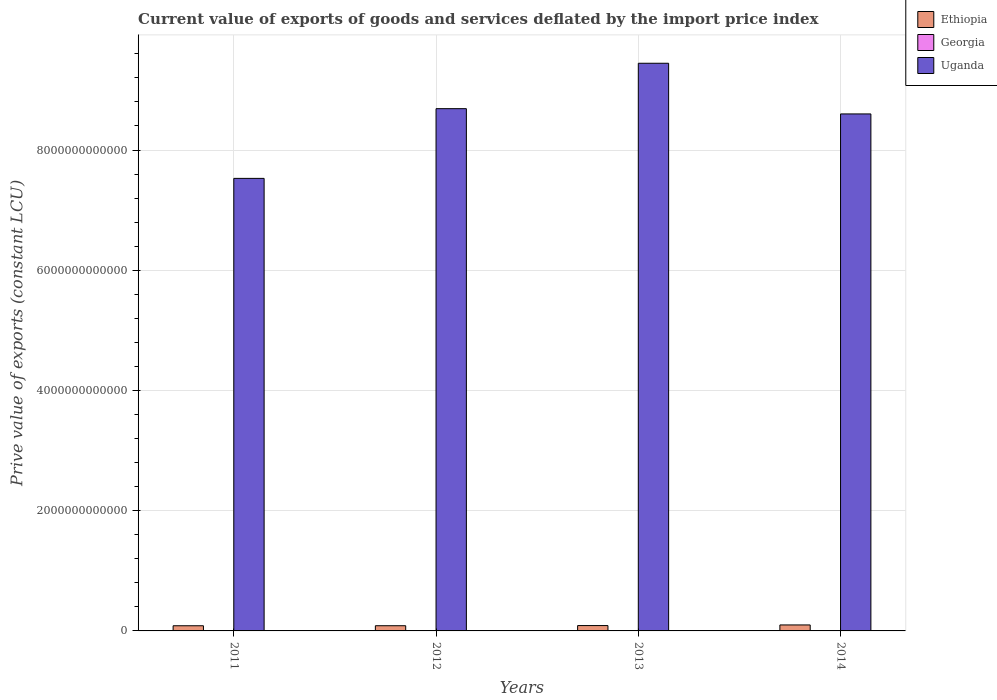How many different coloured bars are there?
Your response must be concise. 3. How many groups of bars are there?
Make the answer very short. 4. Are the number of bars on each tick of the X-axis equal?
Ensure brevity in your answer.  Yes. How many bars are there on the 3rd tick from the left?
Keep it short and to the point. 3. What is the prive value of exports in Ethiopia in 2013?
Your answer should be very brief. 8.91e+1. Across all years, what is the maximum prive value of exports in Georgia?
Keep it short and to the point. 4.46e+09. Across all years, what is the minimum prive value of exports in Uganda?
Offer a terse response. 7.53e+12. What is the total prive value of exports in Georgia in the graph?
Make the answer very short. 1.59e+1. What is the difference between the prive value of exports in Georgia in 2012 and that in 2014?
Keep it short and to the point. -7.93e+08. What is the difference between the prive value of exports in Uganda in 2012 and the prive value of exports in Georgia in 2013?
Make the answer very short. 8.68e+12. What is the average prive value of exports in Ethiopia per year?
Give a very brief answer. 9.02e+1. In the year 2011, what is the difference between the prive value of exports in Uganda and prive value of exports in Georgia?
Make the answer very short. 7.52e+12. What is the ratio of the prive value of exports in Georgia in 2012 to that in 2014?
Your answer should be compact. 0.82. Is the prive value of exports in Georgia in 2011 less than that in 2014?
Ensure brevity in your answer.  Yes. What is the difference between the highest and the second highest prive value of exports in Georgia?
Offer a terse response. 2.30e+07. What is the difference between the highest and the lowest prive value of exports in Georgia?
Your answer should be very brief. 1.18e+09. Is the sum of the prive value of exports in Uganda in 2013 and 2014 greater than the maximum prive value of exports in Georgia across all years?
Make the answer very short. Yes. What does the 3rd bar from the left in 2014 represents?
Give a very brief answer. Uganda. What does the 3rd bar from the right in 2013 represents?
Your answer should be very brief. Ethiopia. Are all the bars in the graph horizontal?
Ensure brevity in your answer.  No. How many years are there in the graph?
Your response must be concise. 4. What is the difference between two consecutive major ticks on the Y-axis?
Ensure brevity in your answer.  2.00e+12. Are the values on the major ticks of Y-axis written in scientific E-notation?
Keep it short and to the point. No. Does the graph contain grids?
Ensure brevity in your answer.  Yes. Where does the legend appear in the graph?
Your answer should be compact. Top right. What is the title of the graph?
Ensure brevity in your answer.  Current value of exports of goods and services deflated by the import price index. Does "Djibouti" appear as one of the legend labels in the graph?
Provide a succinct answer. No. What is the label or title of the Y-axis?
Ensure brevity in your answer.  Prive value of exports (constant LCU). What is the Prive value of exports (constant LCU) of Ethiopia in 2011?
Make the answer very short. 8.60e+1. What is the Prive value of exports (constant LCU) of Georgia in 2011?
Your answer should be compact. 3.28e+09. What is the Prive value of exports (constant LCU) in Uganda in 2011?
Your answer should be very brief. 7.53e+12. What is the Prive value of exports (constant LCU) in Ethiopia in 2012?
Make the answer very short. 8.64e+1. What is the Prive value of exports (constant LCU) of Georgia in 2012?
Give a very brief answer. 3.67e+09. What is the Prive value of exports (constant LCU) in Uganda in 2012?
Make the answer very short. 8.69e+12. What is the Prive value of exports (constant LCU) of Ethiopia in 2013?
Keep it short and to the point. 8.91e+1. What is the Prive value of exports (constant LCU) of Georgia in 2013?
Ensure brevity in your answer.  4.44e+09. What is the Prive value of exports (constant LCU) in Uganda in 2013?
Ensure brevity in your answer.  9.44e+12. What is the Prive value of exports (constant LCU) in Ethiopia in 2014?
Ensure brevity in your answer.  9.95e+1. What is the Prive value of exports (constant LCU) in Georgia in 2014?
Provide a succinct answer. 4.46e+09. What is the Prive value of exports (constant LCU) of Uganda in 2014?
Keep it short and to the point. 8.60e+12. Across all years, what is the maximum Prive value of exports (constant LCU) of Ethiopia?
Your response must be concise. 9.95e+1. Across all years, what is the maximum Prive value of exports (constant LCU) of Georgia?
Your answer should be compact. 4.46e+09. Across all years, what is the maximum Prive value of exports (constant LCU) of Uganda?
Your answer should be very brief. 9.44e+12. Across all years, what is the minimum Prive value of exports (constant LCU) of Ethiopia?
Your answer should be very brief. 8.60e+1. Across all years, what is the minimum Prive value of exports (constant LCU) of Georgia?
Give a very brief answer. 3.28e+09. Across all years, what is the minimum Prive value of exports (constant LCU) in Uganda?
Offer a very short reply. 7.53e+12. What is the total Prive value of exports (constant LCU) of Ethiopia in the graph?
Your answer should be very brief. 3.61e+11. What is the total Prive value of exports (constant LCU) of Georgia in the graph?
Your answer should be compact. 1.59e+1. What is the total Prive value of exports (constant LCU) of Uganda in the graph?
Your response must be concise. 3.43e+13. What is the difference between the Prive value of exports (constant LCU) of Ethiopia in 2011 and that in 2012?
Ensure brevity in your answer.  -4.77e+08. What is the difference between the Prive value of exports (constant LCU) of Georgia in 2011 and that in 2012?
Keep it short and to the point. -3.87e+08. What is the difference between the Prive value of exports (constant LCU) of Uganda in 2011 and that in 2012?
Your answer should be very brief. -1.16e+12. What is the difference between the Prive value of exports (constant LCU) of Ethiopia in 2011 and that in 2013?
Your response must be concise. -3.17e+09. What is the difference between the Prive value of exports (constant LCU) in Georgia in 2011 and that in 2013?
Keep it short and to the point. -1.16e+09. What is the difference between the Prive value of exports (constant LCU) in Uganda in 2011 and that in 2013?
Keep it short and to the point. -1.92e+12. What is the difference between the Prive value of exports (constant LCU) in Ethiopia in 2011 and that in 2014?
Offer a terse response. -1.35e+1. What is the difference between the Prive value of exports (constant LCU) in Georgia in 2011 and that in 2014?
Provide a succinct answer. -1.18e+09. What is the difference between the Prive value of exports (constant LCU) of Uganda in 2011 and that in 2014?
Make the answer very short. -1.07e+12. What is the difference between the Prive value of exports (constant LCU) in Ethiopia in 2012 and that in 2013?
Your answer should be very brief. -2.69e+09. What is the difference between the Prive value of exports (constant LCU) in Georgia in 2012 and that in 2013?
Provide a succinct answer. -7.70e+08. What is the difference between the Prive value of exports (constant LCU) in Uganda in 2012 and that in 2013?
Make the answer very short. -7.55e+11. What is the difference between the Prive value of exports (constant LCU) of Ethiopia in 2012 and that in 2014?
Keep it short and to the point. -1.31e+1. What is the difference between the Prive value of exports (constant LCU) in Georgia in 2012 and that in 2014?
Your response must be concise. -7.93e+08. What is the difference between the Prive value of exports (constant LCU) of Uganda in 2012 and that in 2014?
Provide a succinct answer. 8.75e+1. What is the difference between the Prive value of exports (constant LCU) of Ethiopia in 2013 and that in 2014?
Keep it short and to the point. -1.04e+1. What is the difference between the Prive value of exports (constant LCU) of Georgia in 2013 and that in 2014?
Make the answer very short. -2.30e+07. What is the difference between the Prive value of exports (constant LCU) of Uganda in 2013 and that in 2014?
Ensure brevity in your answer.  8.43e+11. What is the difference between the Prive value of exports (constant LCU) in Ethiopia in 2011 and the Prive value of exports (constant LCU) in Georgia in 2012?
Make the answer very short. 8.23e+1. What is the difference between the Prive value of exports (constant LCU) of Ethiopia in 2011 and the Prive value of exports (constant LCU) of Uganda in 2012?
Your answer should be compact. -8.60e+12. What is the difference between the Prive value of exports (constant LCU) in Georgia in 2011 and the Prive value of exports (constant LCU) in Uganda in 2012?
Provide a short and direct response. -8.68e+12. What is the difference between the Prive value of exports (constant LCU) in Ethiopia in 2011 and the Prive value of exports (constant LCU) in Georgia in 2013?
Your response must be concise. 8.15e+1. What is the difference between the Prive value of exports (constant LCU) in Ethiopia in 2011 and the Prive value of exports (constant LCU) in Uganda in 2013?
Your answer should be compact. -9.36e+12. What is the difference between the Prive value of exports (constant LCU) in Georgia in 2011 and the Prive value of exports (constant LCU) in Uganda in 2013?
Provide a succinct answer. -9.44e+12. What is the difference between the Prive value of exports (constant LCU) of Ethiopia in 2011 and the Prive value of exports (constant LCU) of Georgia in 2014?
Your response must be concise. 8.15e+1. What is the difference between the Prive value of exports (constant LCU) in Ethiopia in 2011 and the Prive value of exports (constant LCU) in Uganda in 2014?
Ensure brevity in your answer.  -8.51e+12. What is the difference between the Prive value of exports (constant LCU) of Georgia in 2011 and the Prive value of exports (constant LCU) of Uganda in 2014?
Ensure brevity in your answer.  -8.60e+12. What is the difference between the Prive value of exports (constant LCU) of Ethiopia in 2012 and the Prive value of exports (constant LCU) of Georgia in 2013?
Your response must be concise. 8.20e+1. What is the difference between the Prive value of exports (constant LCU) of Ethiopia in 2012 and the Prive value of exports (constant LCU) of Uganda in 2013?
Your response must be concise. -9.36e+12. What is the difference between the Prive value of exports (constant LCU) in Georgia in 2012 and the Prive value of exports (constant LCU) in Uganda in 2013?
Offer a very short reply. -9.44e+12. What is the difference between the Prive value of exports (constant LCU) in Ethiopia in 2012 and the Prive value of exports (constant LCU) in Georgia in 2014?
Make the answer very short. 8.20e+1. What is the difference between the Prive value of exports (constant LCU) in Ethiopia in 2012 and the Prive value of exports (constant LCU) in Uganda in 2014?
Keep it short and to the point. -8.51e+12. What is the difference between the Prive value of exports (constant LCU) in Georgia in 2012 and the Prive value of exports (constant LCU) in Uganda in 2014?
Keep it short and to the point. -8.60e+12. What is the difference between the Prive value of exports (constant LCU) in Ethiopia in 2013 and the Prive value of exports (constant LCU) in Georgia in 2014?
Make the answer very short. 8.47e+1. What is the difference between the Prive value of exports (constant LCU) of Ethiopia in 2013 and the Prive value of exports (constant LCU) of Uganda in 2014?
Keep it short and to the point. -8.51e+12. What is the difference between the Prive value of exports (constant LCU) of Georgia in 2013 and the Prive value of exports (constant LCU) of Uganda in 2014?
Ensure brevity in your answer.  -8.60e+12. What is the average Prive value of exports (constant LCU) in Ethiopia per year?
Offer a terse response. 9.02e+1. What is the average Prive value of exports (constant LCU) in Georgia per year?
Keep it short and to the point. 3.96e+09. What is the average Prive value of exports (constant LCU) in Uganda per year?
Your answer should be very brief. 8.57e+12. In the year 2011, what is the difference between the Prive value of exports (constant LCU) in Ethiopia and Prive value of exports (constant LCU) in Georgia?
Provide a short and direct response. 8.27e+1. In the year 2011, what is the difference between the Prive value of exports (constant LCU) in Ethiopia and Prive value of exports (constant LCU) in Uganda?
Make the answer very short. -7.44e+12. In the year 2011, what is the difference between the Prive value of exports (constant LCU) of Georgia and Prive value of exports (constant LCU) of Uganda?
Your response must be concise. -7.52e+12. In the year 2012, what is the difference between the Prive value of exports (constant LCU) of Ethiopia and Prive value of exports (constant LCU) of Georgia?
Offer a very short reply. 8.28e+1. In the year 2012, what is the difference between the Prive value of exports (constant LCU) of Ethiopia and Prive value of exports (constant LCU) of Uganda?
Offer a very short reply. -8.60e+12. In the year 2012, what is the difference between the Prive value of exports (constant LCU) of Georgia and Prive value of exports (constant LCU) of Uganda?
Offer a very short reply. -8.68e+12. In the year 2013, what is the difference between the Prive value of exports (constant LCU) in Ethiopia and Prive value of exports (constant LCU) in Georgia?
Your answer should be compact. 8.47e+1. In the year 2013, what is the difference between the Prive value of exports (constant LCU) of Ethiopia and Prive value of exports (constant LCU) of Uganda?
Your answer should be very brief. -9.35e+12. In the year 2013, what is the difference between the Prive value of exports (constant LCU) of Georgia and Prive value of exports (constant LCU) of Uganda?
Offer a very short reply. -9.44e+12. In the year 2014, what is the difference between the Prive value of exports (constant LCU) in Ethiopia and Prive value of exports (constant LCU) in Georgia?
Give a very brief answer. 9.50e+1. In the year 2014, what is the difference between the Prive value of exports (constant LCU) in Ethiopia and Prive value of exports (constant LCU) in Uganda?
Provide a short and direct response. -8.50e+12. In the year 2014, what is the difference between the Prive value of exports (constant LCU) of Georgia and Prive value of exports (constant LCU) of Uganda?
Your answer should be compact. -8.60e+12. What is the ratio of the Prive value of exports (constant LCU) in Ethiopia in 2011 to that in 2012?
Give a very brief answer. 0.99. What is the ratio of the Prive value of exports (constant LCU) in Georgia in 2011 to that in 2012?
Give a very brief answer. 0.89. What is the ratio of the Prive value of exports (constant LCU) in Uganda in 2011 to that in 2012?
Your response must be concise. 0.87. What is the ratio of the Prive value of exports (constant LCU) of Ethiopia in 2011 to that in 2013?
Make the answer very short. 0.96. What is the ratio of the Prive value of exports (constant LCU) of Georgia in 2011 to that in 2013?
Provide a succinct answer. 0.74. What is the ratio of the Prive value of exports (constant LCU) in Uganda in 2011 to that in 2013?
Your answer should be compact. 0.8. What is the ratio of the Prive value of exports (constant LCU) in Ethiopia in 2011 to that in 2014?
Make the answer very short. 0.86. What is the ratio of the Prive value of exports (constant LCU) in Georgia in 2011 to that in 2014?
Your answer should be very brief. 0.74. What is the ratio of the Prive value of exports (constant LCU) in Uganda in 2011 to that in 2014?
Keep it short and to the point. 0.88. What is the ratio of the Prive value of exports (constant LCU) in Ethiopia in 2012 to that in 2013?
Keep it short and to the point. 0.97. What is the ratio of the Prive value of exports (constant LCU) of Georgia in 2012 to that in 2013?
Make the answer very short. 0.83. What is the ratio of the Prive value of exports (constant LCU) in Ethiopia in 2012 to that in 2014?
Provide a succinct answer. 0.87. What is the ratio of the Prive value of exports (constant LCU) in Georgia in 2012 to that in 2014?
Ensure brevity in your answer.  0.82. What is the ratio of the Prive value of exports (constant LCU) in Uganda in 2012 to that in 2014?
Your response must be concise. 1.01. What is the ratio of the Prive value of exports (constant LCU) in Ethiopia in 2013 to that in 2014?
Provide a succinct answer. 0.9. What is the ratio of the Prive value of exports (constant LCU) of Uganda in 2013 to that in 2014?
Give a very brief answer. 1.1. What is the difference between the highest and the second highest Prive value of exports (constant LCU) of Ethiopia?
Offer a very short reply. 1.04e+1. What is the difference between the highest and the second highest Prive value of exports (constant LCU) of Georgia?
Offer a very short reply. 2.30e+07. What is the difference between the highest and the second highest Prive value of exports (constant LCU) of Uganda?
Your answer should be compact. 7.55e+11. What is the difference between the highest and the lowest Prive value of exports (constant LCU) of Ethiopia?
Give a very brief answer. 1.35e+1. What is the difference between the highest and the lowest Prive value of exports (constant LCU) of Georgia?
Your answer should be very brief. 1.18e+09. What is the difference between the highest and the lowest Prive value of exports (constant LCU) in Uganda?
Offer a terse response. 1.92e+12. 